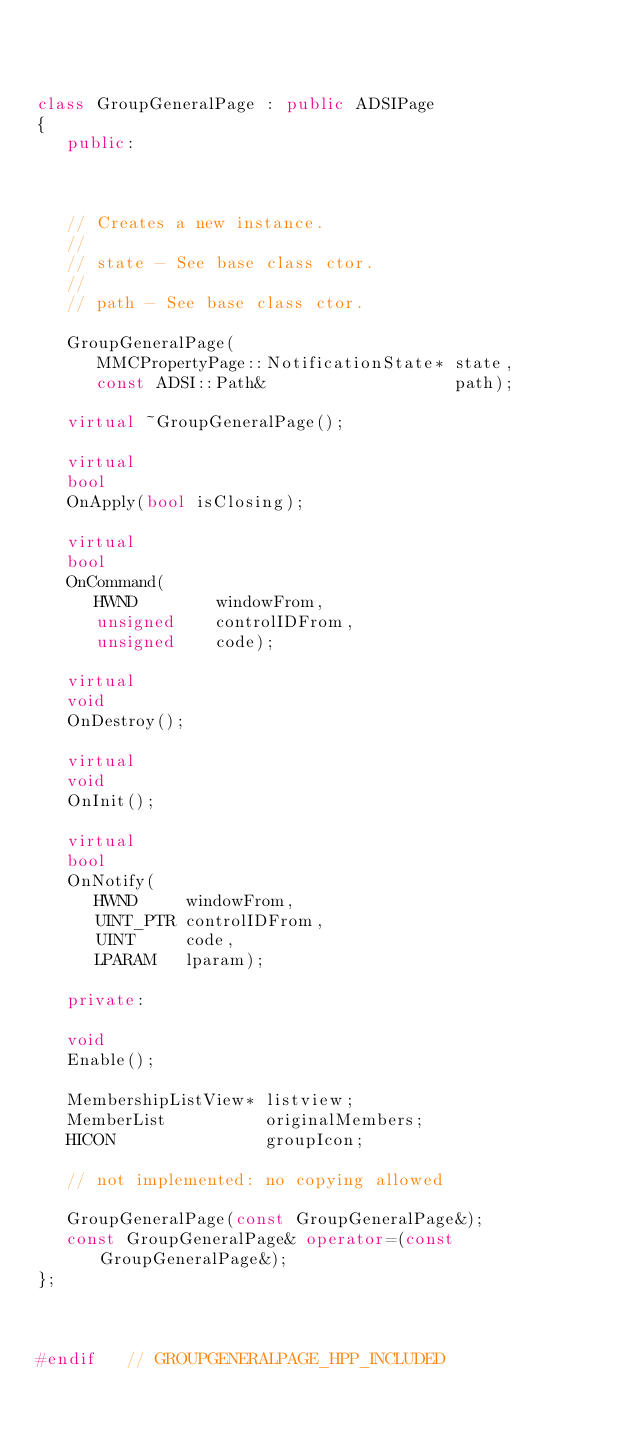<code> <loc_0><loc_0><loc_500><loc_500><_C++_>


class GroupGeneralPage : public ADSIPage
{
   public:


   
   // Creates a new instance.
   // 
   // state - See base class ctor.
   //
   // path - See base class ctor.

   GroupGeneralPage(
      MMCPropertyPage::NotificationState* state,
      const ADSI::Path&                   path);

   virtual ~GroupGeneralPage();

   virtual
   bool
   OnApply(bool isClosing);

   virtual
   bool
   OnCommand(
      HWND        windowFrom,
      unsigned    controlIDFrom,
      unsigned    code);

   virtual
   void
   OnDestroy();

   virtual
   void
   OnInit();

   virtual
   bool
   OnNotify(
      HWND     windowFrom,
      UINT_PTR controlIDFrom,
      UINT     code,
      LPARAM   lparam);

   private:

   void
   Enable();

   MembershipListView* listview;        
   MemberList          originalMembers;
   HICON               groupIcon;       
                                      
   // not implemented: no copying allowed

   GroupGeneralPage(const GroupGeneralPage&);
   const GroupGeneralPage& operator=(const GroupGeneralPage&);
};



#endif   // GROUPGENERALPAGE_HPP_INCLUDED
</code> 